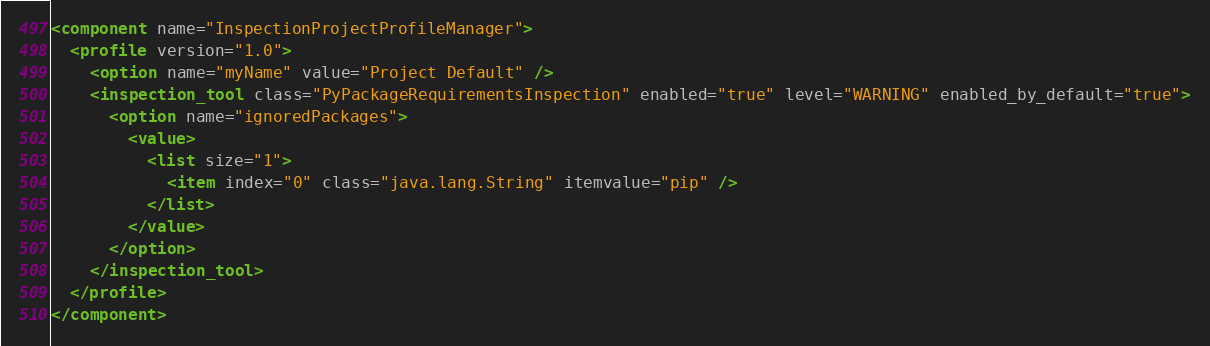<code> <loc_0><loc_0><loc_500><loc_500><_XML_><component name="InspectionProjectProfileManager">
  <profile version="1.0">
    <option name="myName" value="Project Default" />
    <inspection_tool class="PyPackageRequirementsInspection" enabled="true" level="WARNING" enabled_by_default="true">
      <option name="ignoredPackages">
        <value>
          <list size="1">
            <item index="0" class="java.lang.String" itemvalue="pip" />
          </list>
        </value>
      </option>
    </inspection_tool>
  </profile>
</component></code> 